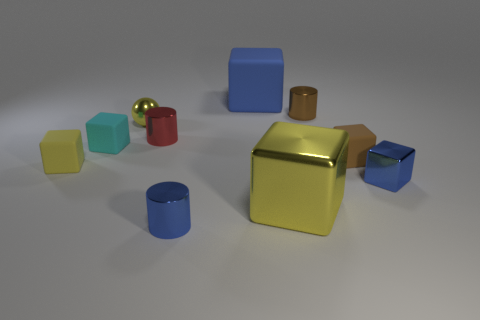How many other things are the same size as the ball?
Offer a terse response. 7. There is a small yellow thing that is the same shape as the brown matte thing; what is its material?
Give a very brief answer. Rubber. What number of other things are there of the same shape as the big yellow thing?
Provide a short and direct response. 5. How many cyan rubber things are behind the small blue thing to the left of the tiny brown block in front of the blue matte cube?
Ensure brevity in your answer.  1. How many big gray matte things are the same shape as the large yellow shiny object?
Provide a short and direct response. 0. Does the big thing that is in front of the tiny yellow metal thing have the same color as the small ball?
Ensure brevity in your answer.  Yes. The large object that is behind the blue cube in front of the tiny matte block that is right of the cyan block is what shape?
Offer a very short reply. Cube. There is a brown block; does it have the same size as the yellow cube that is left of the yellow shiny sphere?
Your response must be concise. Yes. Is there a red thing that has the same size as the ball?
Offer a very short reply. Yes. What number of other things are made of the same material as the tiny brown cylinder?
Your answer should be very brief. 5. 